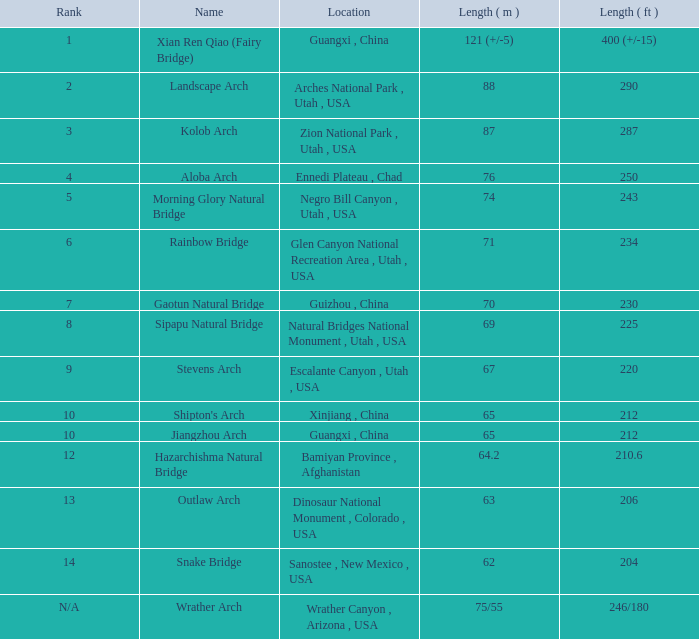What is the distance in feet of the jiangzhou arch? 212.0. 